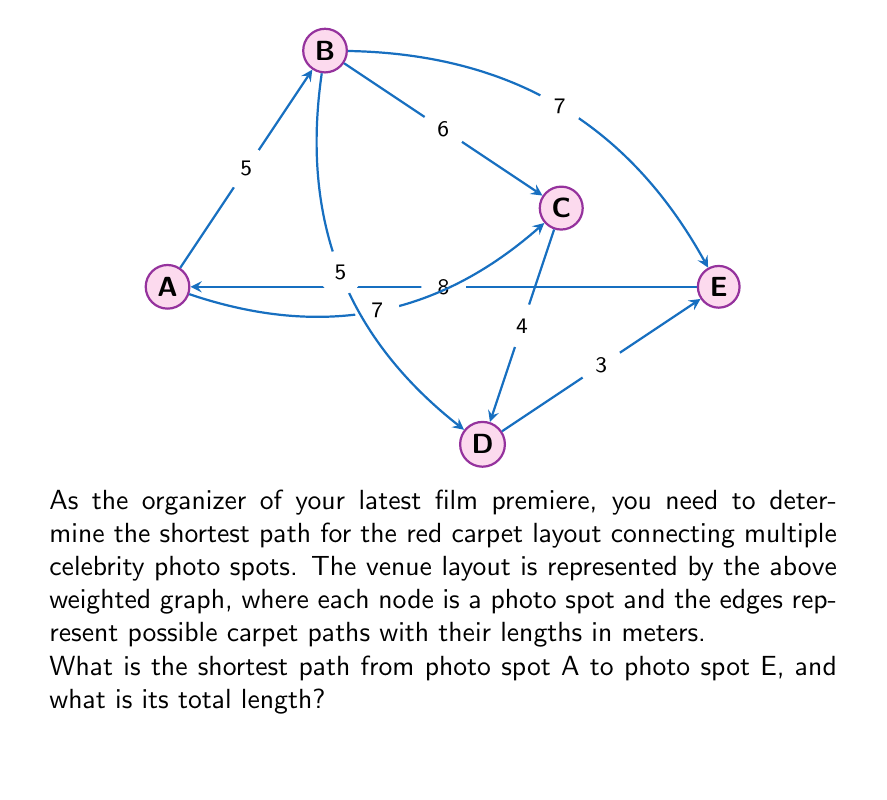Can you answer this question? To solve this problem, we'll use Dijkstra's algorithm to find the shortest path from A to E.

Step 1: Initialize distances
- Set distance to A as 0
- Set distances to all other nodes as infinity

Step 2: Visit node A
- Update distances:
  B: min(∞, 0 + 5) = 5
  C: min(∞, 0 + 7) = 7
  E: min(∞, 0 + 8) = 8

Step 3: Visit node B (shortest unvisited)
- Update distances:
  C: min(7, 5 + 6) = 7 (no change)
  D: min(∞, 5 + 5) = 10
  E: min(8, 5 + 7) = 8 (no change)

Step 4: Visit node C
- Update distances:
  D: min(10, 7 + 4) = 10 (no change)
  E: min(8, 7 + 3) = 8 (no change)

Step 5: Visit node E (destination reached)

The shortest path is A → B → E with a total length of 5 + 7 = 12 meters.
Answer: A → B → E, 12 meters 